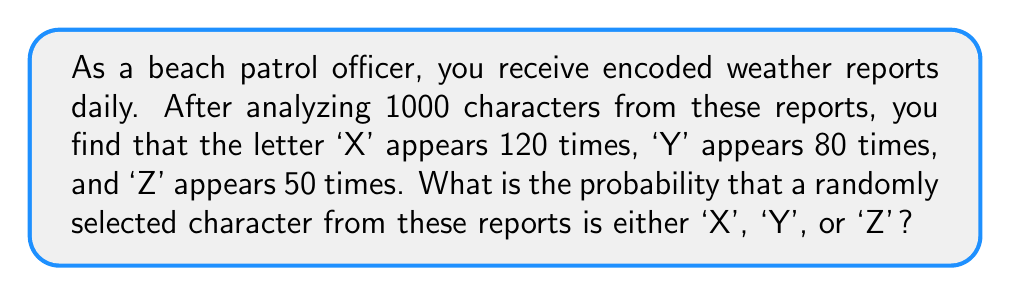Can you solve this math problem? Let's approach this step-by-step:

1) First, we need to calculate the total number of occurrences of 'X', 'Y', and 'Z':
   $120 + 80 + 50 = 250$

2) Now, we need to calculate the probability. The probability is the number of favorable outcomes divided by the total number of possible outcomes.

3) In this case:
   - Favorable outcomes: 250 (the number of times 'X', 'Y', or 'Z' appears)
   - Total possible outcomes: 1000 (the total number of characters analyzed)

4) The probability is therefore:

   $$P(\text{X or Y or Z}) = \frac{250}{1000} = \frac{1}{4} = 0.25$$

5) We can also express this as a percentage:
   $0.25 \times 100\% = 25\%$

Therefore, the probability that a randomly selected character is either 'X', 'Y', or 'Z' is 0.25 or 25%.
Answer: 0.25 